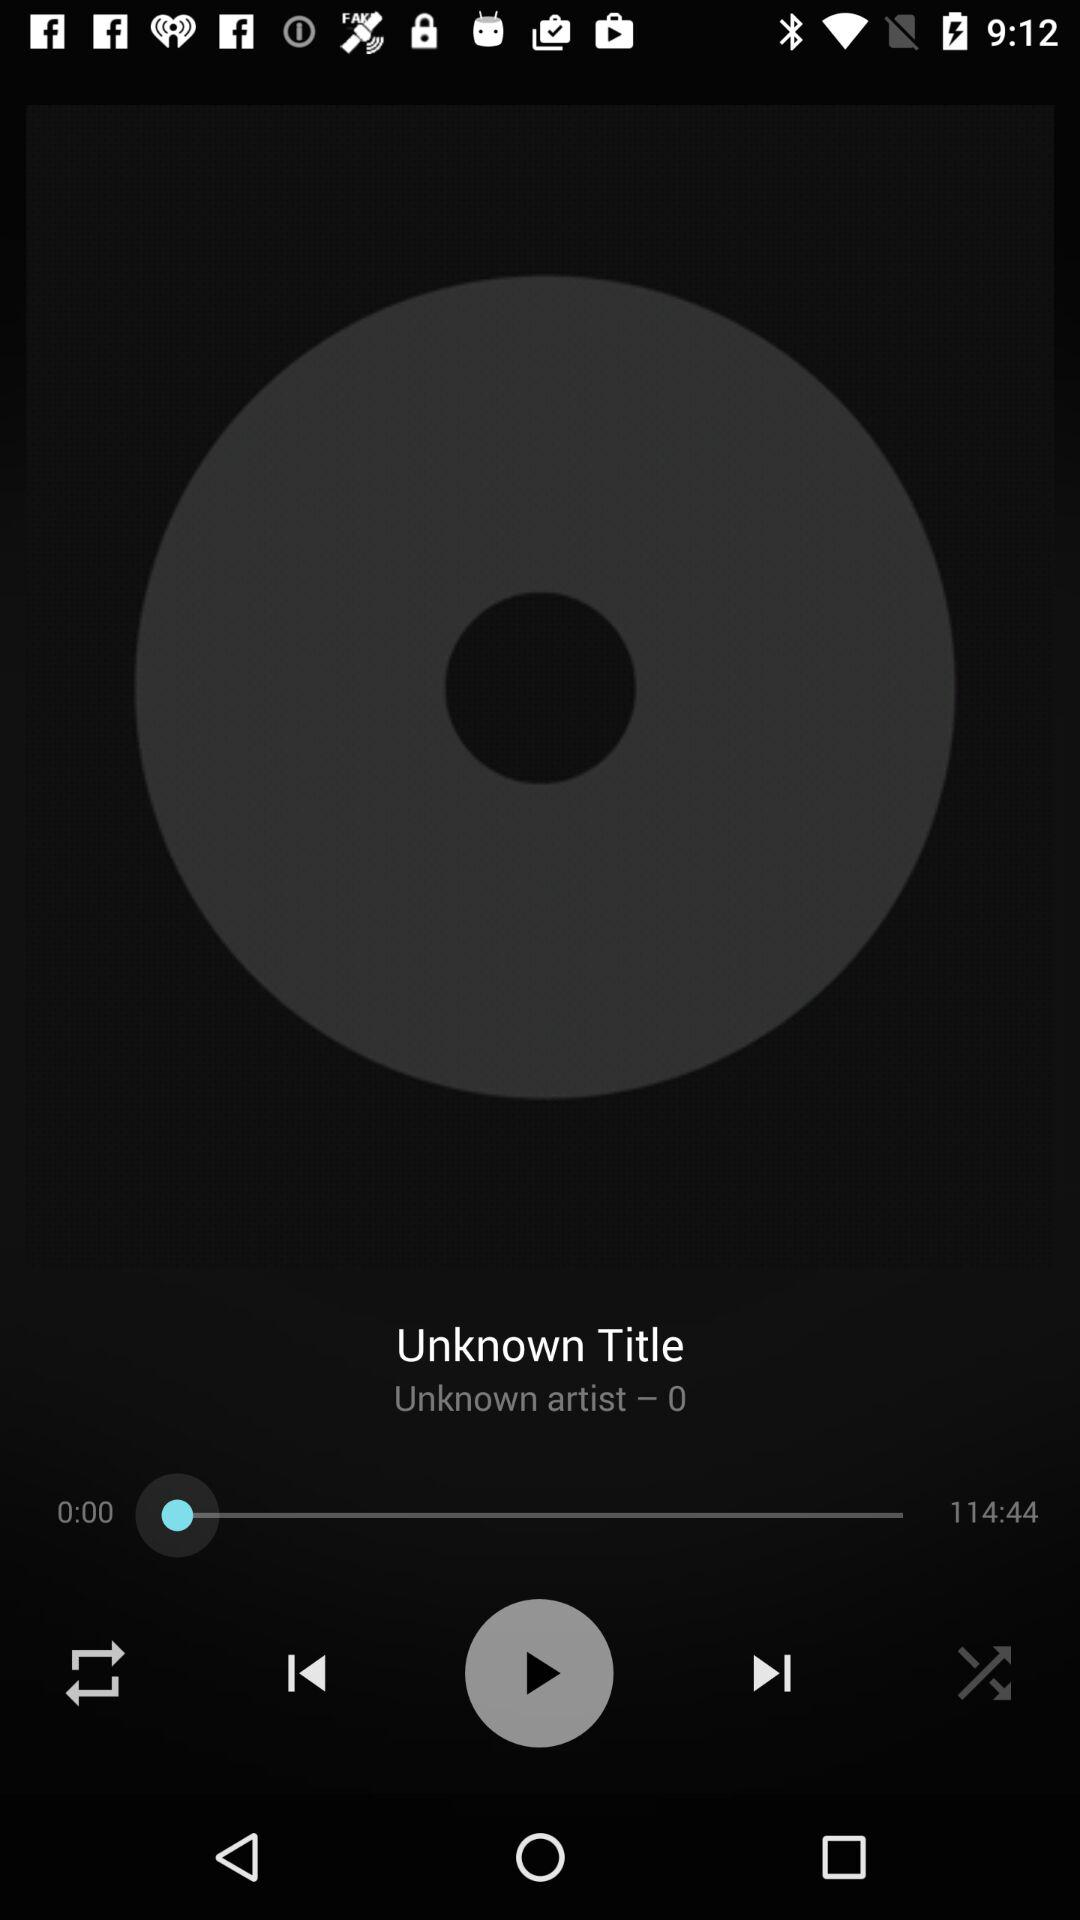What is the length of a song? The length of the song is 114:44. 